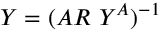Convert formula to latex. <formula><loc_0><loc_0><loc_500><loc_500>Y = ( A R Y ^ { A } ) ^ { - 1 }</formula> 